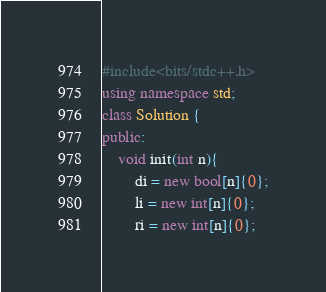<code> <loc_0><loc_0><loc_500><loc_500><_C++_>#include<bits/stdc++.h>
using namespace std;
class Solution {
public:
    void init(int n){
        di = new bool[n]{0};
        li = new int[n]{0};
        ri = new int[n]{0};</code> 